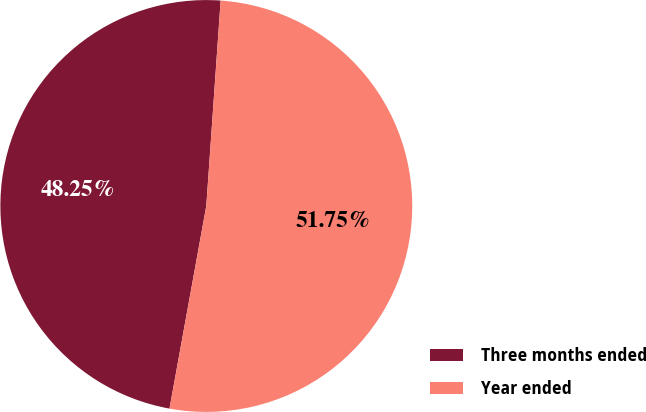<chart> <loc_0><loc_0><loc_500><loc_500><pie_chart><fcel>Three months ended<fcel>Year ended<nl><fcel>48.25%<fcel>51.75%<nl></chart> 